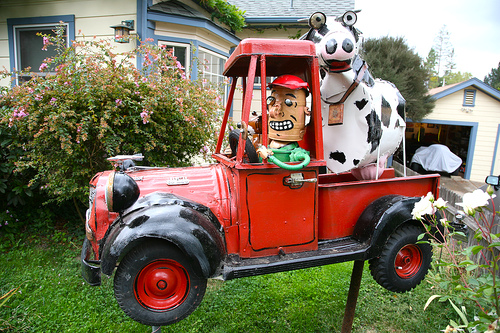<image>
Is the toy cow in the jeep? Yes. The toy cow is contained within or inside the jeep, showing a containment relationship. Where is the toy in relation to the truck? Is it in the truck? Yes. The toy is contained within or inside the truck, showing a containment relationship. Is the toy car in front of the plants? Yes. The toy car is positioned in front of the plants, appearing closer to the camera viewpoint. 